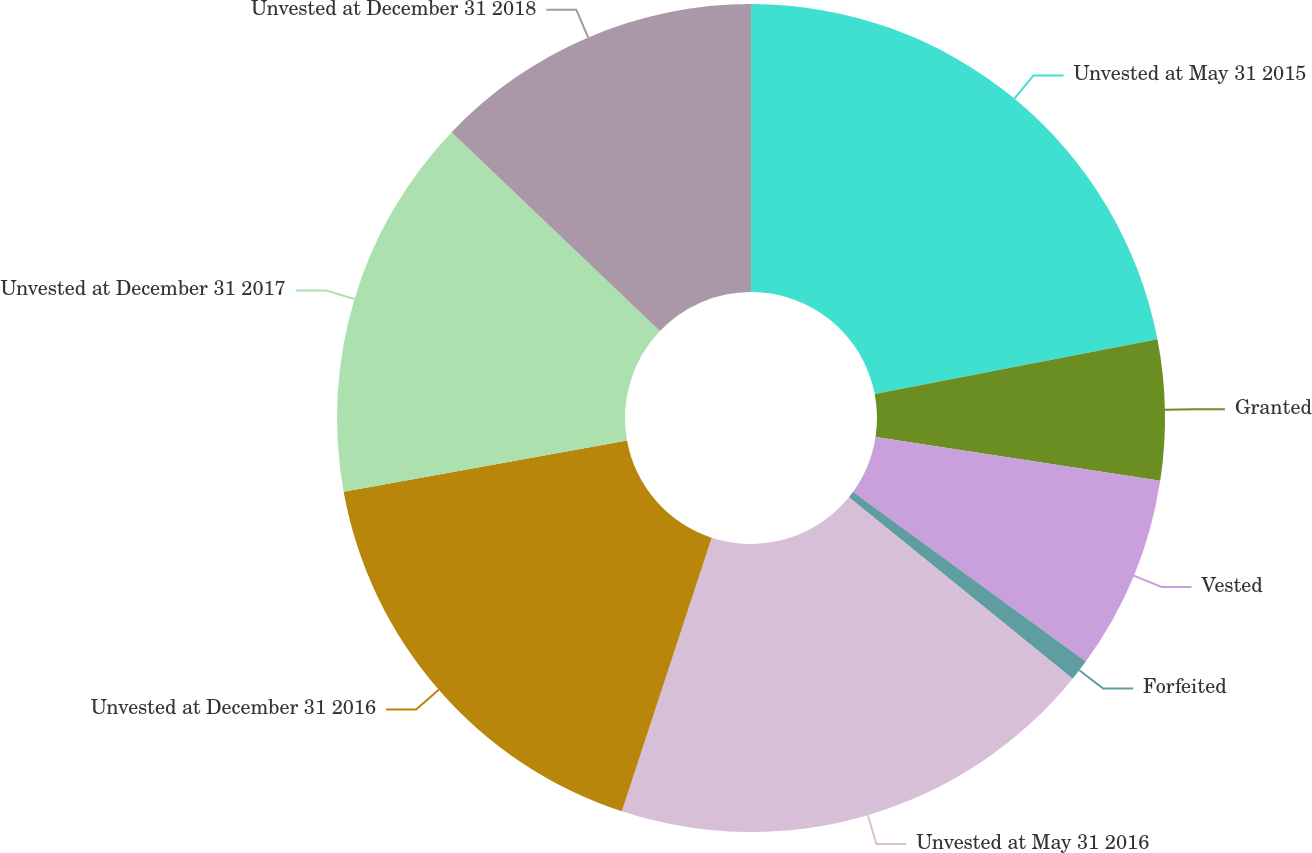Convert chart. <chart><loc_0><loc_0><loc_500><loc_500><pie_chart><fcel>Unvested at May 31 2015<fcel>Granted<fcel>Vested<fcel>Forfeited<fcel>Unvested at May 31 2016<fcel>Unvested at December 31 2016<fcel>Unvested at December 31 2017<fcel>Unvested at December 31 2018<nl><fcel>21.95%<fcel>5.47%<fcel>7.59%<fcel>0.83%<fcel>19.21%<fcel>17.1%<fcel>14.98%<fcel>12.87%<nl></chart> 